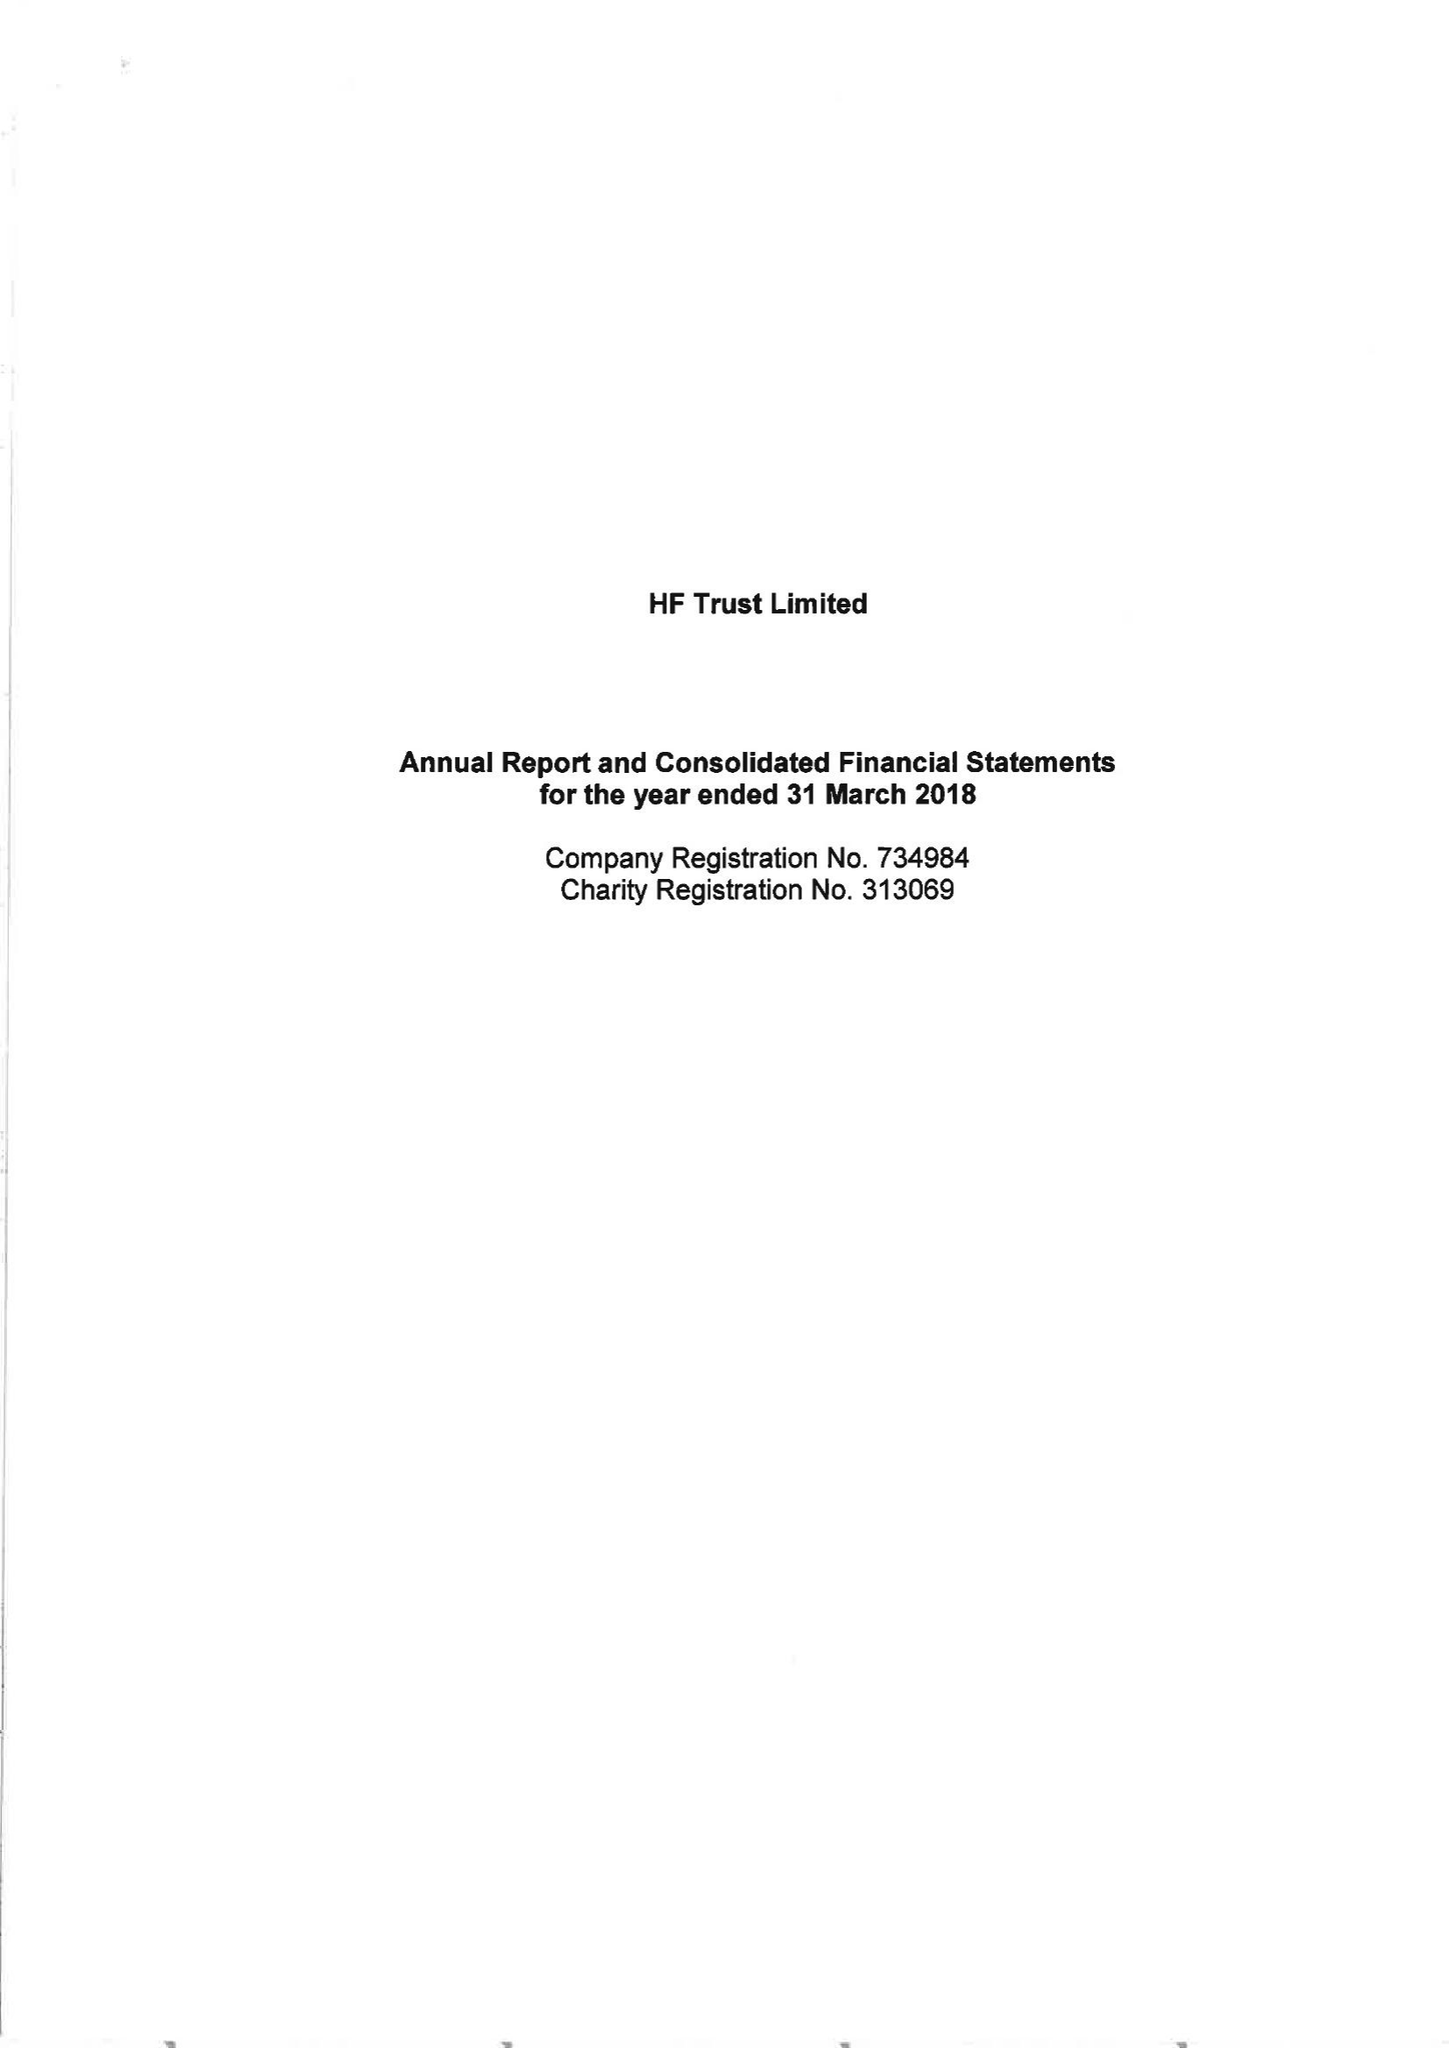What is the value for the report_date?
Answer the question using a single word or phrase. 2018-03-31 